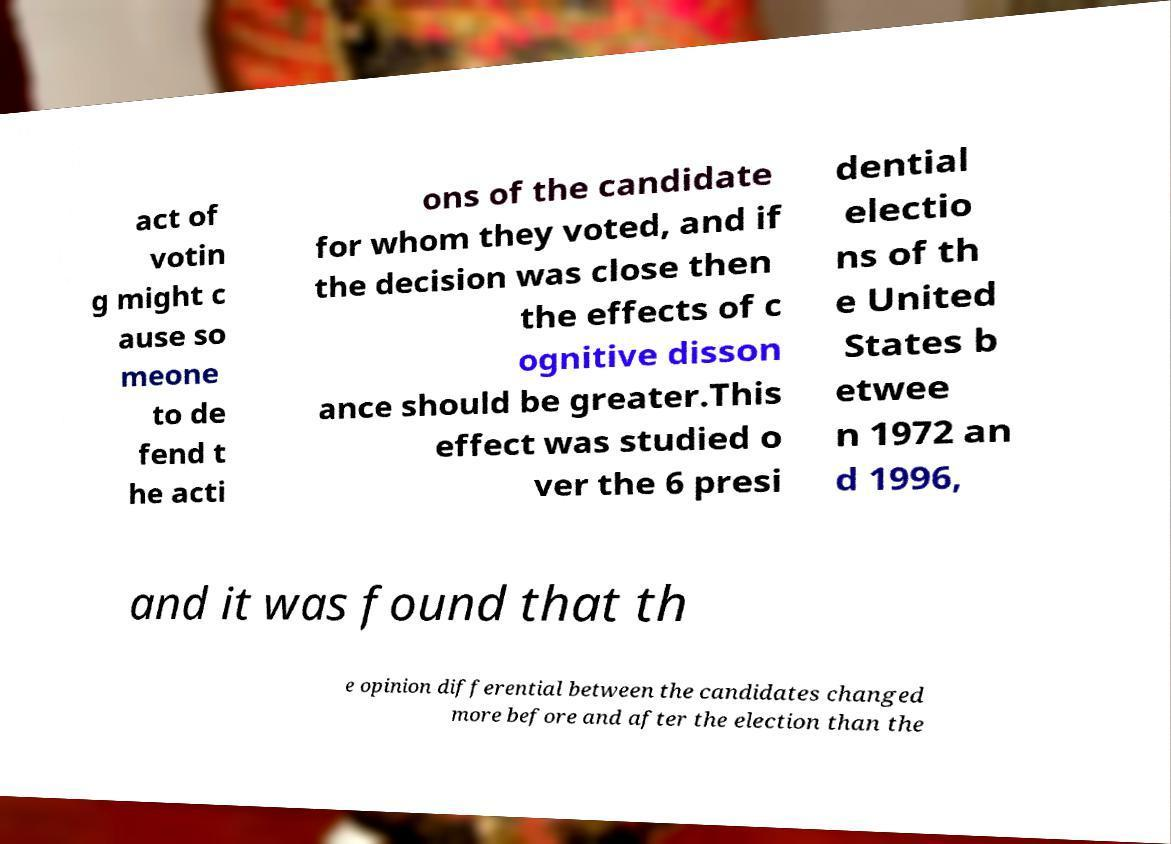Please read and relay the text visible in this image. What does it say? act of votin g might c ause so meone to de fend t he acti ons of the candidate for whom they voted, and if the decision was close then the effects of c ognitive disson ance should be greater.This effect was studied o ver the 6 presi dential electio ns of th e United States b etwee n 1972 an d 1996, and it was found that th e opinion differential between the candidates changed more before and after the election than the 